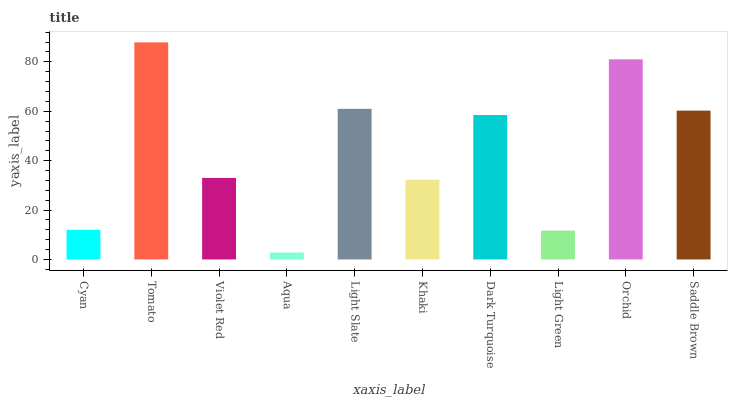Is Aqua the minimum?
Answer yes or no. Yes. Is Tomato the maximum?
Answer yes or no. Yes. Is Violet Red the minimum?
Answer yes or no. No. Is Violet Red the maximum?
Answer yes or no. No. Is Tomato greater than Violet Red?
Answer yes or no. Yes. Is Violet Red less than Tomato?
Answer yes or no. Yes. Is Violet Red greater than Tomato?
Answer yes or no. No. Is Tomato less than Violet Red?
Answer yes or no. No. Is Dark Turquoise the high median?
Answer yes or no. Yes. Is Violet Red the low median?
Answer yes or no. Yes. Is Khaki the high median?
Answer yes or no. No. Is Tomato the low median?
Answer yes or no. No. 